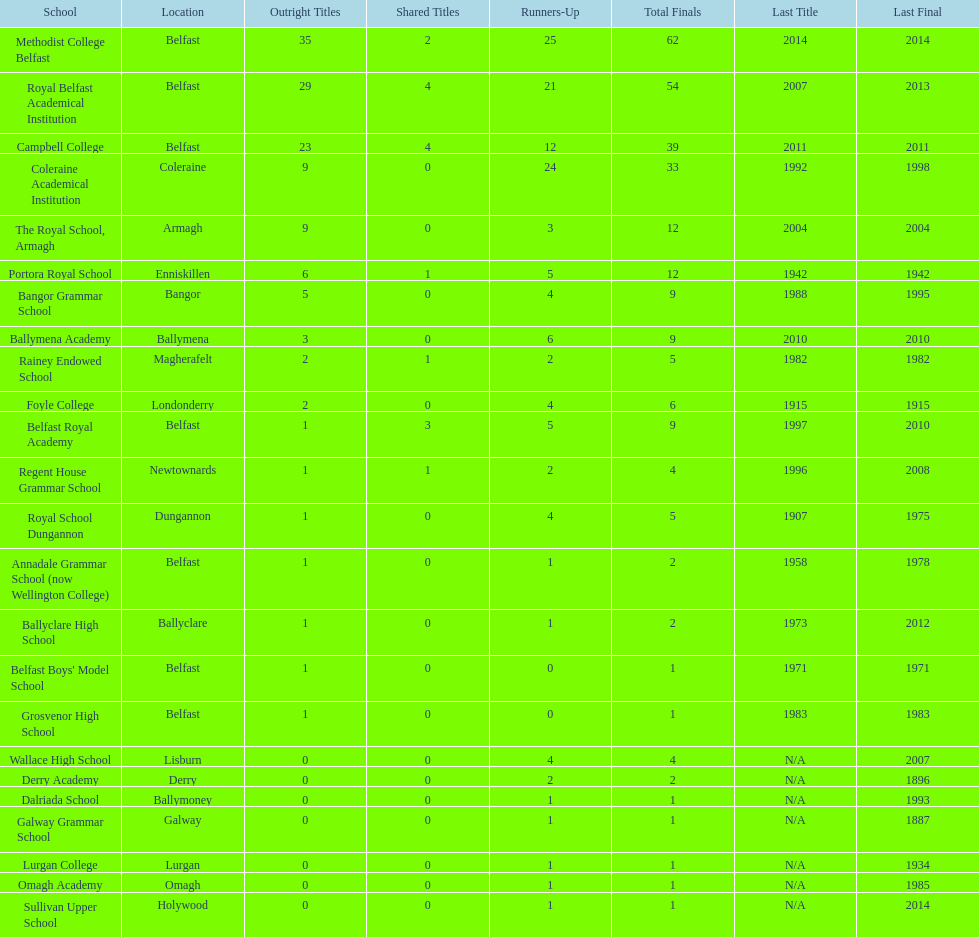How many educational institutions possess 5 or more outright titles? 7. 